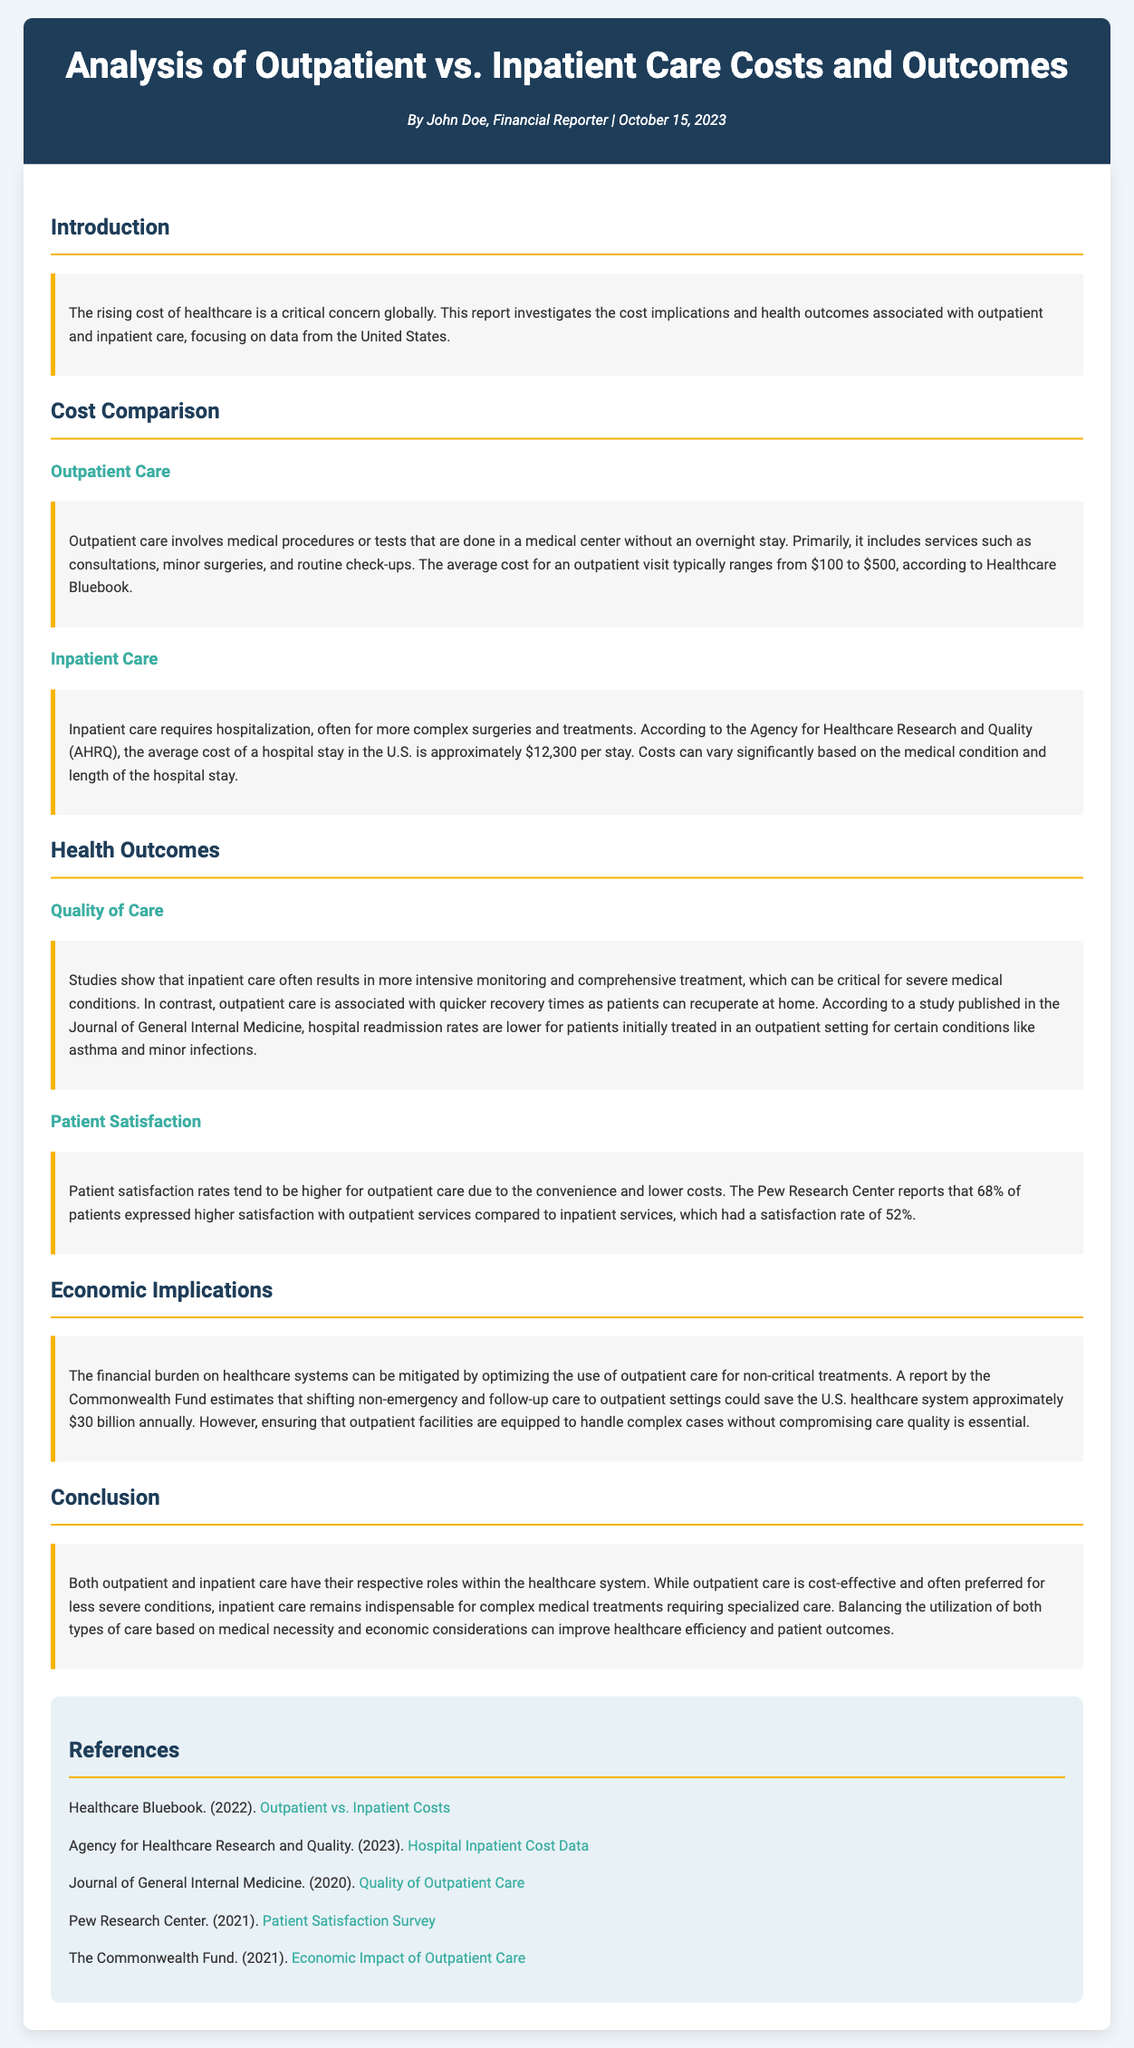what is the average cost of an outpatient visit? The document states that the average cost for an outpatient visit typically ranges from $100 to $500.
Answer: $100 to $500 what is the average cost of a hospital stay in the U.S.? According to the Agency for Healthcare Research and Quality, the average cost of a hospital stay in the U.S. is approximately $12,300 per stay.
Answer: $12,300 which organization reports higher patient satisfaction with outpatient services? The Pew Research Center reports that 68% of patients expressed higher satisfaction with outpatient services.
Answer: Pew Research Center what is the estimated annual savings for the U.S. healthcare system by shifting to outpatient care? A report by the Commonwealth Fund estimates that shifting non-emergency and follow-up care to outpatient settings could save the U.S. healthcare system approximately $30 billion annually.
Answer: $30 billion which condition is mentioned to have lower hospital readmission rates when treated outpatiently? The document mentions that asthma and minor infections have lower hospital readmission rates when initially treated in an outpatient setting.
Answer: asthma and minor infections what percentage of patients expressed satisfaction with inpatient services? The document states that inpatient services had a satisfaction rate of 52%.
Answer: 52% what is a key benefit of outpatient care noted in the report? According to the report, outpatient care is associated with quicker recovery times as patients can recuperate at home.
Answer: quicker recovery times what is the primary concern regarding outpatient care infrastructure? Ensuring that outpatient facilities are equipped to handle complex cases without compromising care quality is essential.
Answer: care quality 